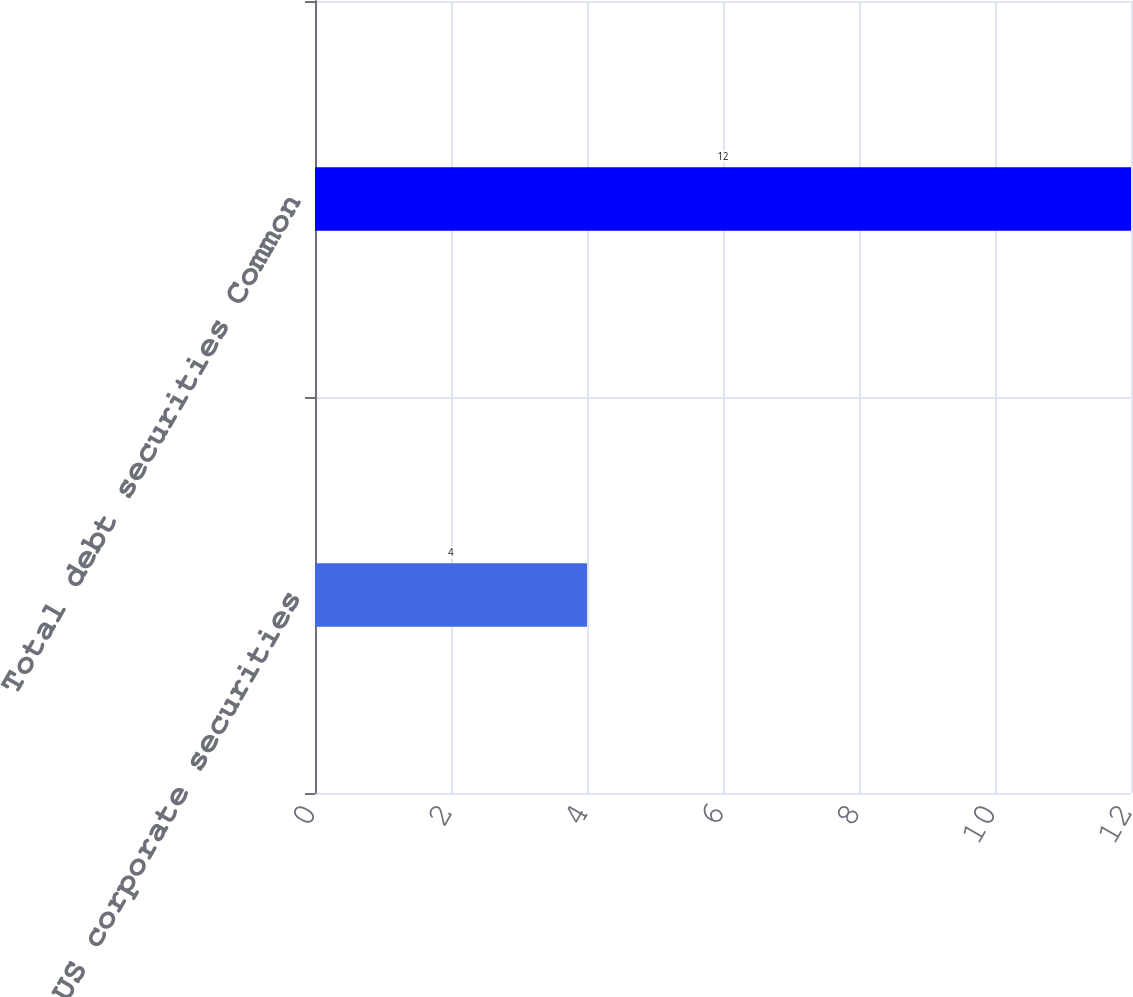Convert chart to OTSL. <chart><loc_0><loc_0><loc_500><loc_500><bar_chart><fcel>US corporate securities<fcel>Total debt securities Common<nl><fcel>4<fcel>12<nl></chart> 